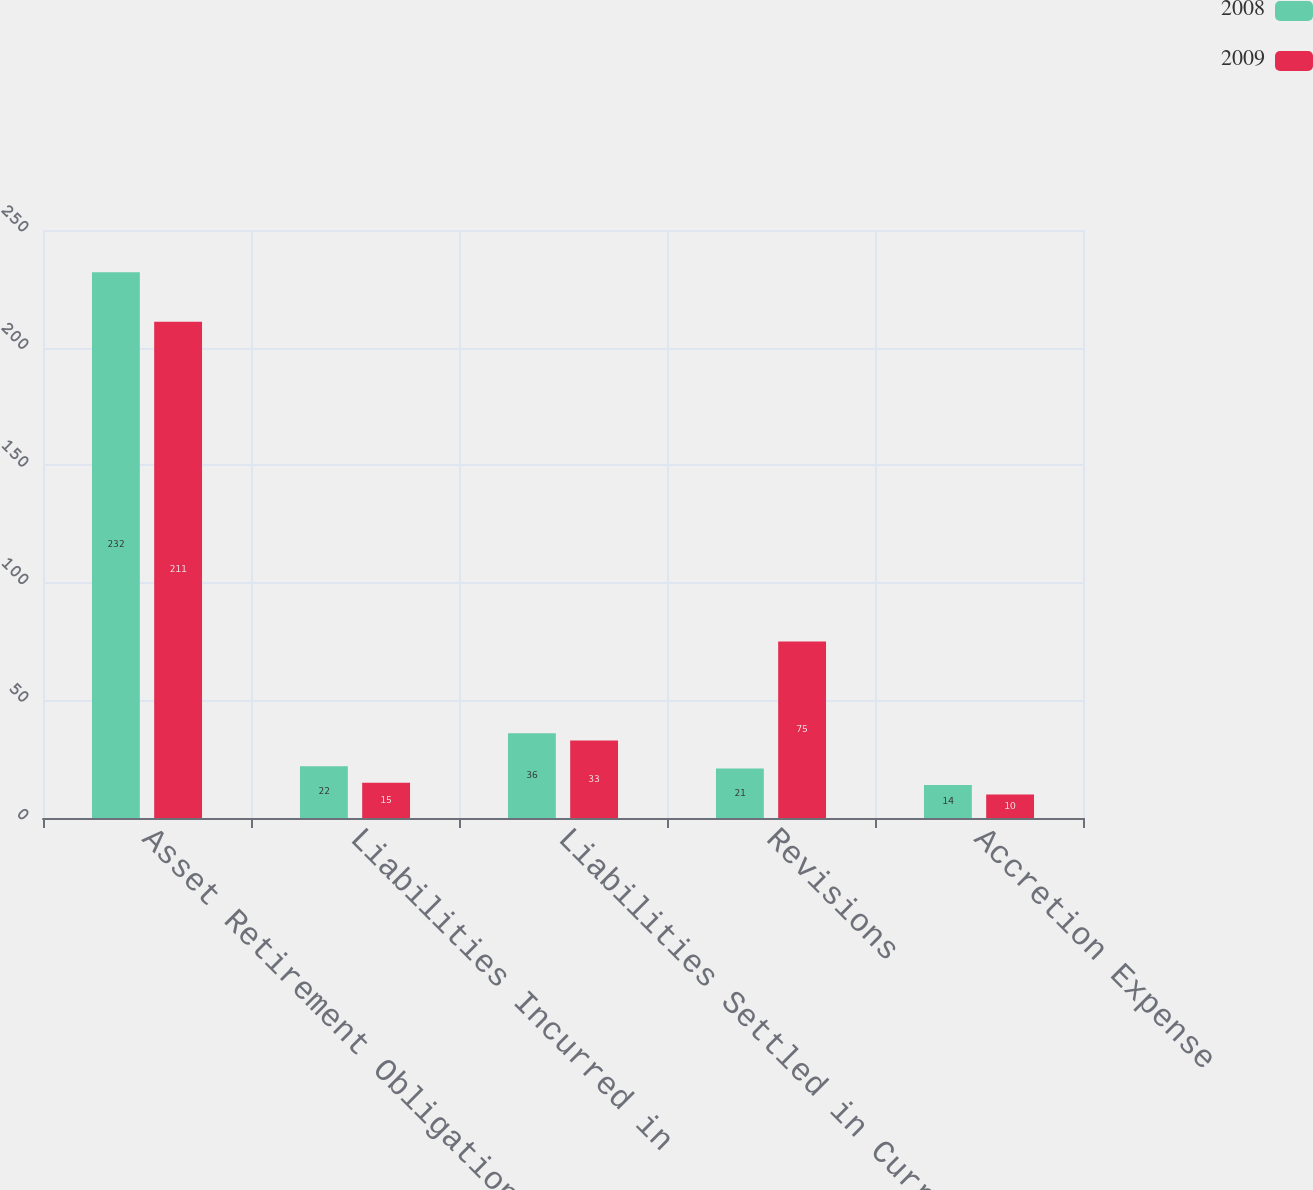Convert chart. <chart><loc_0><loc_0><loc_500><loc_500><stacked_bar_chart><ecel><fcel>Asset Retirement Obligations<fcel>Liabilities Incurred in<fcel>Liabilities Settled in Current<fcel>Revisions<fcel>Accretion Expense<nl><fcel>2008<fcel>232<fcel>22<fcel>36<fcel>21<fcel>14<nl><fcel>2009<fcel>211<fcel>15<fcel>33<fcel>75<fcel>10<nl></chart> 